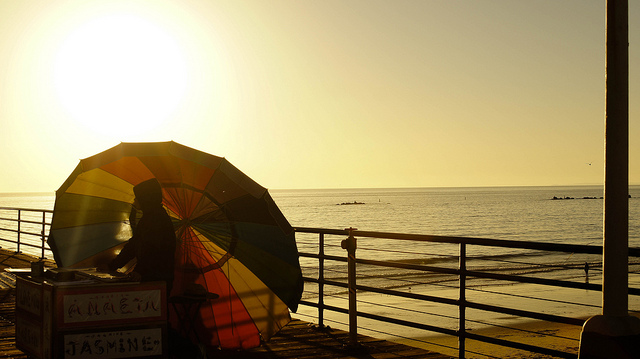Can you describe the time of day this picture might have been taken? The long shadows and the golden hue suggests that this photo was taken around sunrise or sunset. The low angle of the sun on the horizon indicates that it is either early in the morning or late in the afternoon. 